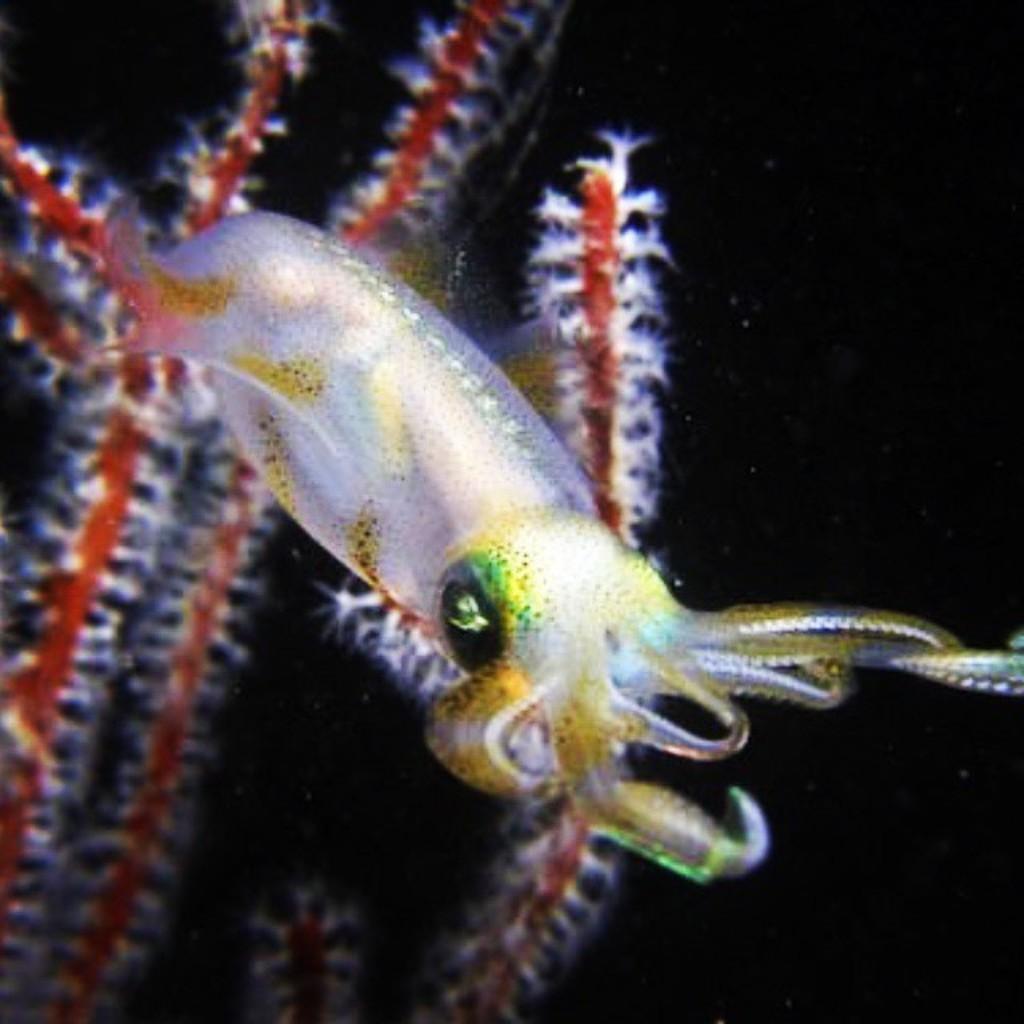Could you give a brief overview of what you see in this image? In this image I can see a white colour squid. I can also see few red colour things and I can see black colour in background. 